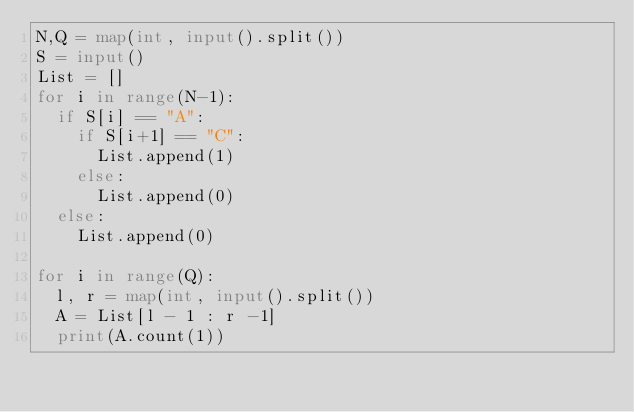Convert code to text. <code><loc_0><loc_0><loc_500><loc_500><_Python_>N,Q = map(int, input().split())
S = input()
List = []
for i in range(N-1):
  if S[i] == "A":
    if S[i+1] == "C":
      List.append(1)
    else:
      List.append(0)
  else:
    List.append(0)

for i in range(Q):
  l, r = map(int, input().split())
  A = List[l - 1 : r -1]
  print(A.count(1))</code> 